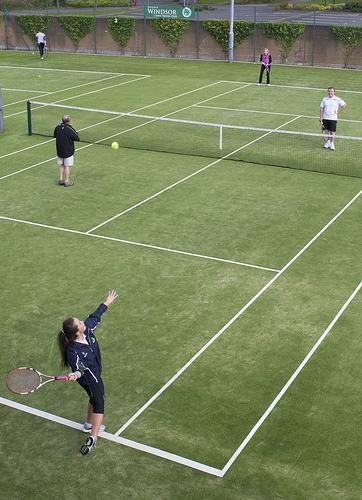How many people seen on the court?
Give a very brief answer. 5. How many people are pictured?
Give a very brief answer. 5. How many players on each side?
Give a very brief answer. 2. How many people can be seen here?
Give a very brief answer. 5. 